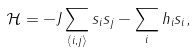<formula> <loc_0><loc_0><loc_500><loc_500>\mathcal { H } = - J \sum _ { \langle i , j \rangle } s _ { i } s _ { j } - \sum _ { i } h _ { i } s _ { i } ,</formula> 